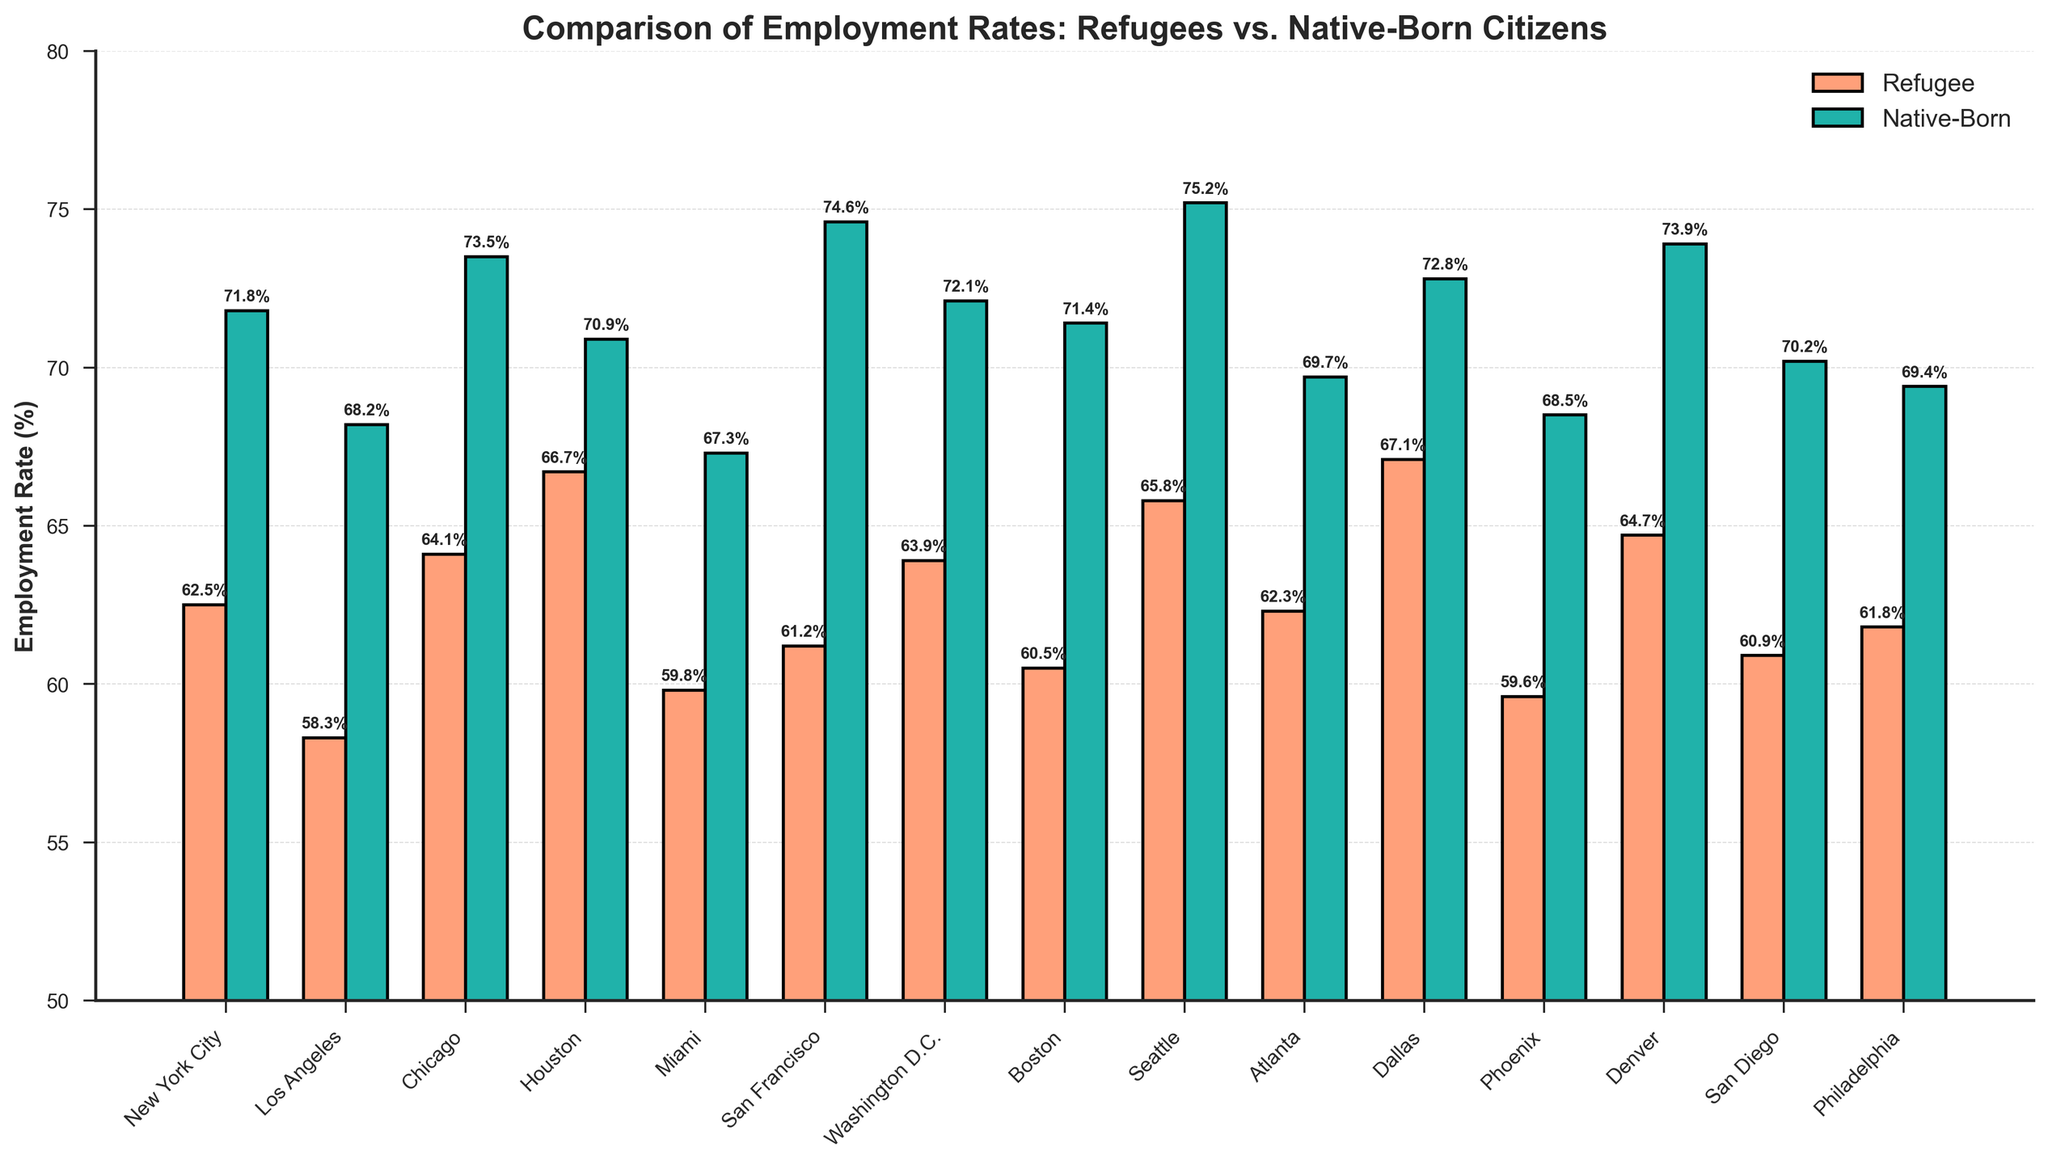Which city has the highest refugee employment rate? To determine the city with the highest refugee employment rate, we compare the refugee employment rates listed for each city. Houston has the highest rate at 67.1%.
Answer: Houston What is the average employment rate for native-born citizens across all cities? To find the average, sum the native-born employment rates and divide by the number of cities: (71.8+68.2+73.5+70.9+67.3+74.6+72.1+71.4+75.2+69.7+72.8+68.5+73.9+70.2+69.4)/15 = 71.4%.
Answer: 71.4% How much higher is the native-born employment rate in Seattle compared to the refugee employment rate in Seattle? Subtract the refugee employment rate from the native-born employment rate in Seattle: 75.2% - 65.8% = 9.4%.
Answer: 9.4% Which city has the smallest difference between refugee and native-born employment rates? Calculate the difference for each city and compare: New York City (9.3), Los Angeles (9.9), Chicago (9.4), Houston (4.2), Miami (7.5), San Francisco (13.4), Washington D.C. (8.2), Boston (10.9), Seattle (9.4), Atlanta (7.4), Dallas (5.7), Phoenix (8.9), Denver (9.2), San Diego (9.3), Philadelphia (7.6). The smallest difference is in Houston.
Answer: Houston What is the total employment rate sum for refugees in Chicago, Houston, and Miami? Sum the refugee employment rates for these cities: 64.1% + 66.7% + 59.8% = 190.6%.
Answer: 190.6% Which employment group (refugee or native-born) has a higher rate in more cities? Count the number of cities where native-born rates are higher (all cities), and for refugees (none). Native-born rates are higher in all the cities.
Answer: Native-born What is the average difference between refugee and native-born employment rates across all cities? Calculate the differences for all cities, sum them up, and divide by the number of cities: (9.3 + 9.9 + 9.4 + 4.2 + 7.5 + 13.4 + 8.2 + 10.9 + 9.4 + 7.4 + 5.7 + 8.9 + 9.2 + 9.3 + 7.6) / 15 ≈ 8.6%.
Answer: 8.6% 